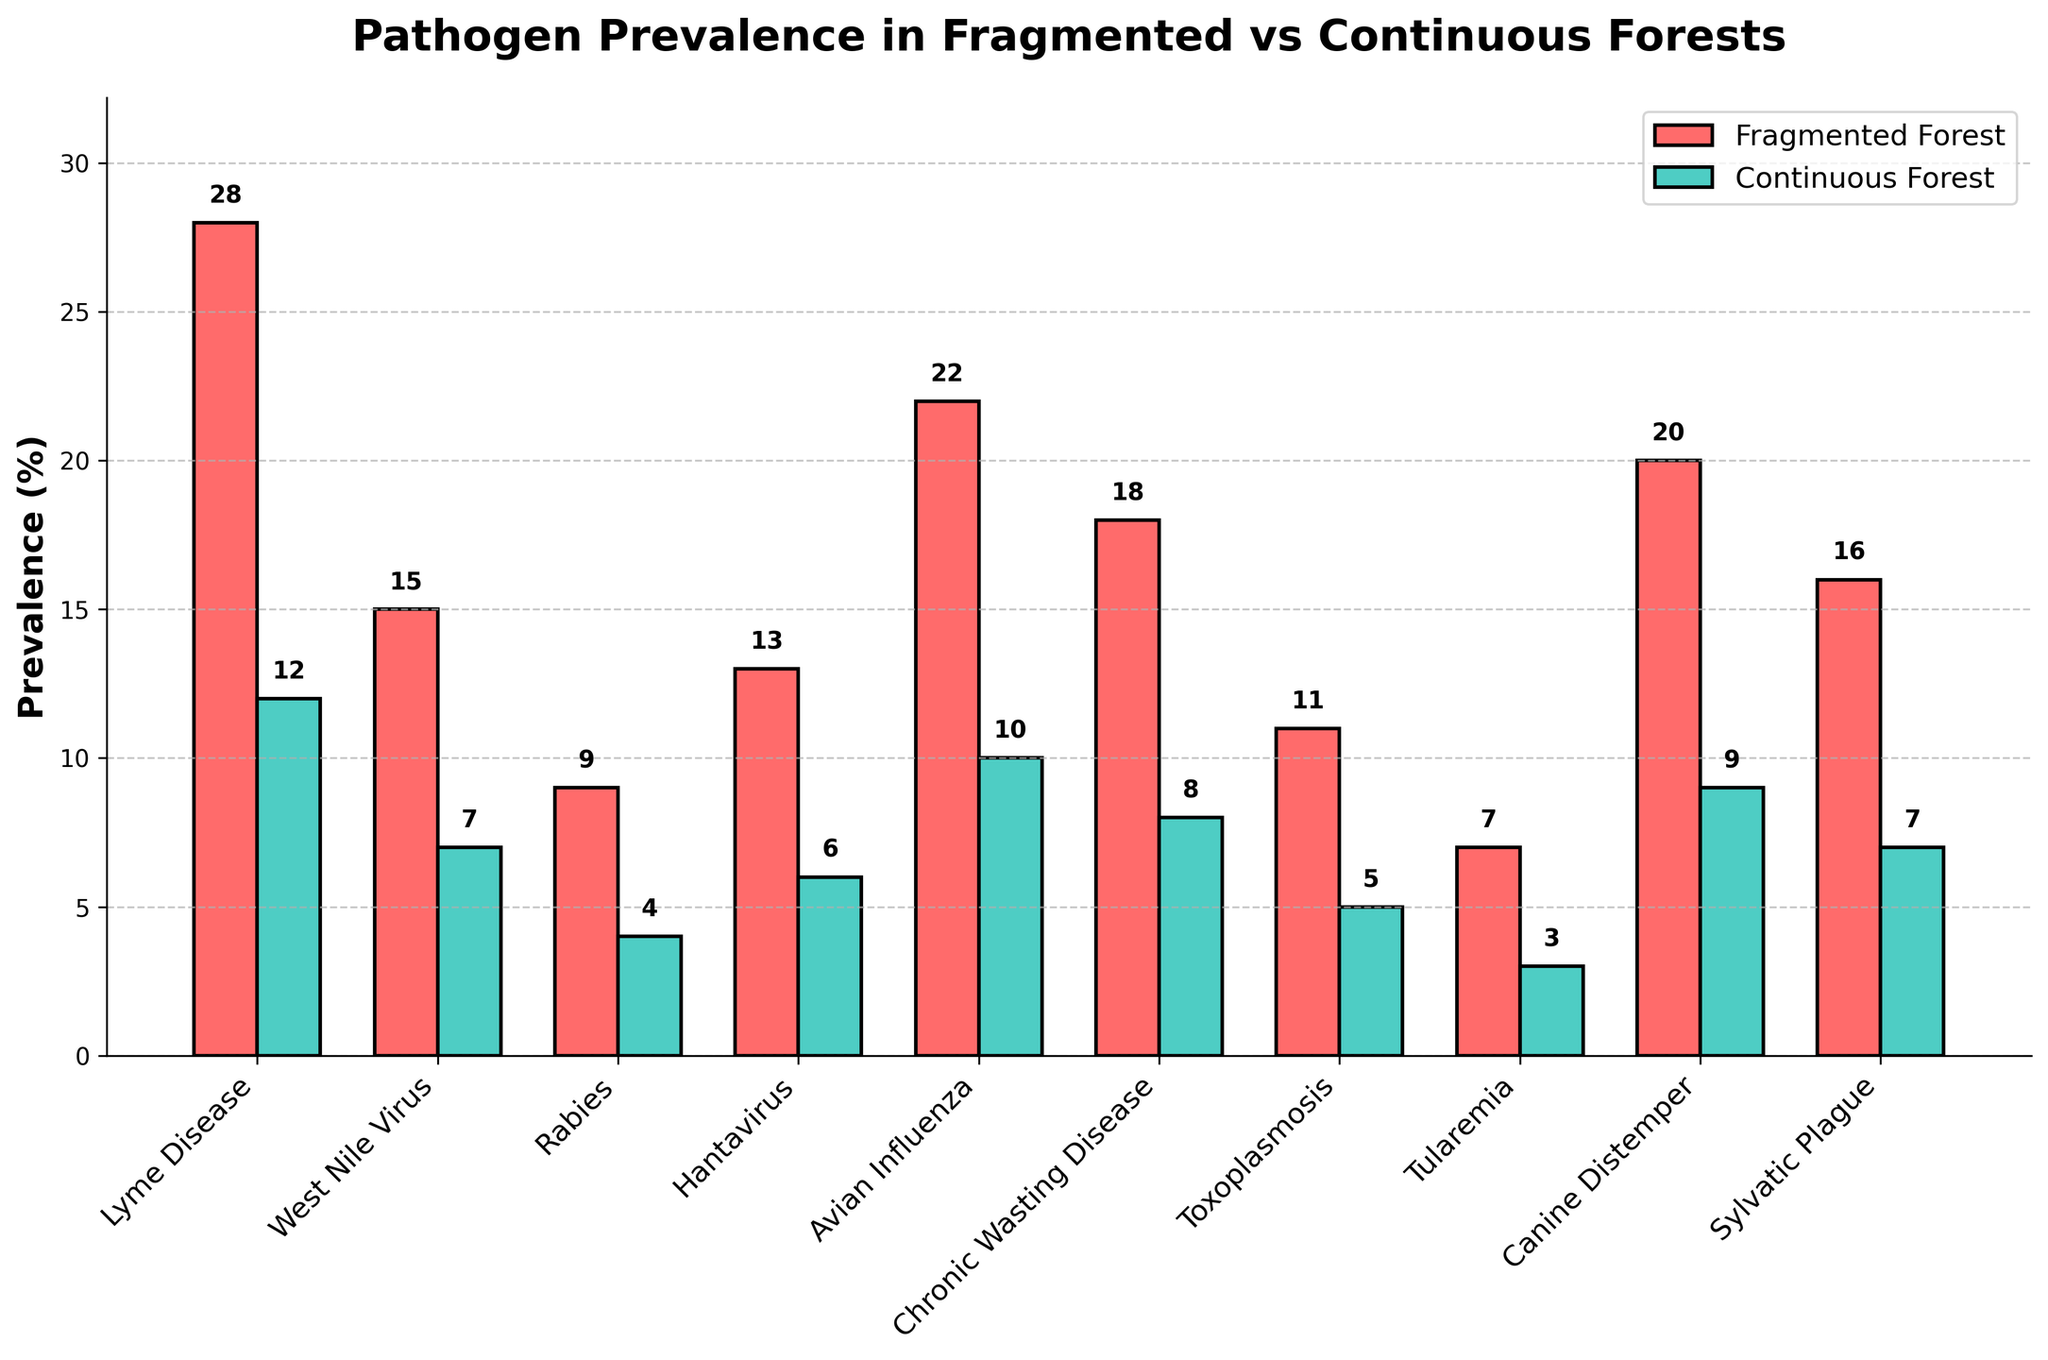What's the title of the figure? The title is located at the top of the figure. It reads "Pathogen Prevalence in Fragmented vs Continuous Forests".
Answer: Pathogen Prevalence in Fragmented vs Continuous Forests What is the prevalence of Lyme Disease in fragmented forests? The prevalence of Lyme Disease in fragmented forests is displayed as a red bar with an annotation above it. According to the annotation, the prevalence is 28%.
Answer: 28% Which forest type has a higher prevalence of Avian Influenza? To determine which forest type has a higher prevalence, compare the heights of the bars for Avian Influenza. The red bar (fragmented forest) is higher than the teal bar (continuous forest), indicating a higher prevalence in fragmented forests.
Answer: Fragmented forest What's the average prevalence of Hantavirus in both forest types combined? The prevalence of Hantavirus is 13% in fragmented forests and 6% in continuous forests. The average is calculated as (13 + 6)/2 = 19/2 = 9.5.
Answer: 9.5% How many pathogens show a higher prevalence in fragmented forests compared to continuous forests? To answer this, compare the heights of the bars for each pathogen. Every red bar (fragmented forest) is taller than its corresponding teal bar (continuous forest). Counting these, we have 10 pathogens.
Answer: 10 What's the total prevalence of Rabies in both forest types? The prevalence of Rabies is 9% in fragmented forests and 4% in continuous forests. Summing them, we get 9 + 4 = 13.
Answer: 13% Which pathogen has the highest prevalence in fragmented forests? By comparing the heights of the red bars and their annotations, Lyme Disease has the highest prevalence in fragmented forests at 28%.
Answer: Lyme Disease How much higher is the prevalence of Chronic Wasting Disease in fragmented forests compared to continuous forests? The prevalence of Chronic Wasting Disease is 18% in fragmented forests and 8% in continuous forests. The difference is 18 - 8 = 10.
Answer: 10% What's the sum of the prevalences of Toxoplasmosis and Tularemia in continuous forests? The prevalence of Toxoplasmosis in continuous forests is 5% and for Tularemia, it is 3%. The total sum is 5 + 3 = 8.
Answer: 8% Is there any pathogen with equal prevalence in both forest types? By examining the heights of the paired bars for each pathogen, no pathogen has precisely equal heights of the red and teal bars, indicating no equal prevalence.
Answer: No 